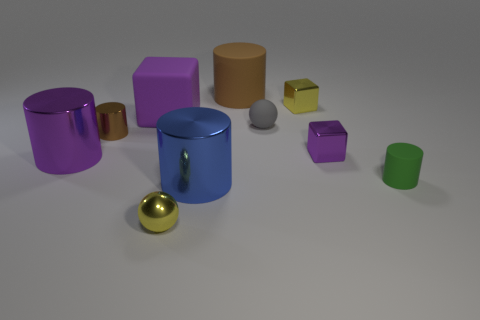Subtract all purple metallic cylinders. How many cylinders are left? 4 Subtract all blue cylinders. How many cylinders are left? 4 Subtract all red cylinders. Subtract all green spheres. How many cylinders are left? 5 Subtract all spheres. How many objects are left? 8 Subtract all small green rubber things. Subtract all large green objects. How many objects are left? 9 Add 5 purple shiny blocks. How many purple shiny blocks are left? 6 Add 8 large rubber objects. How many large rubber objects exist? 10 Subtract 1 blue cylinders. How many objects are left? 9 